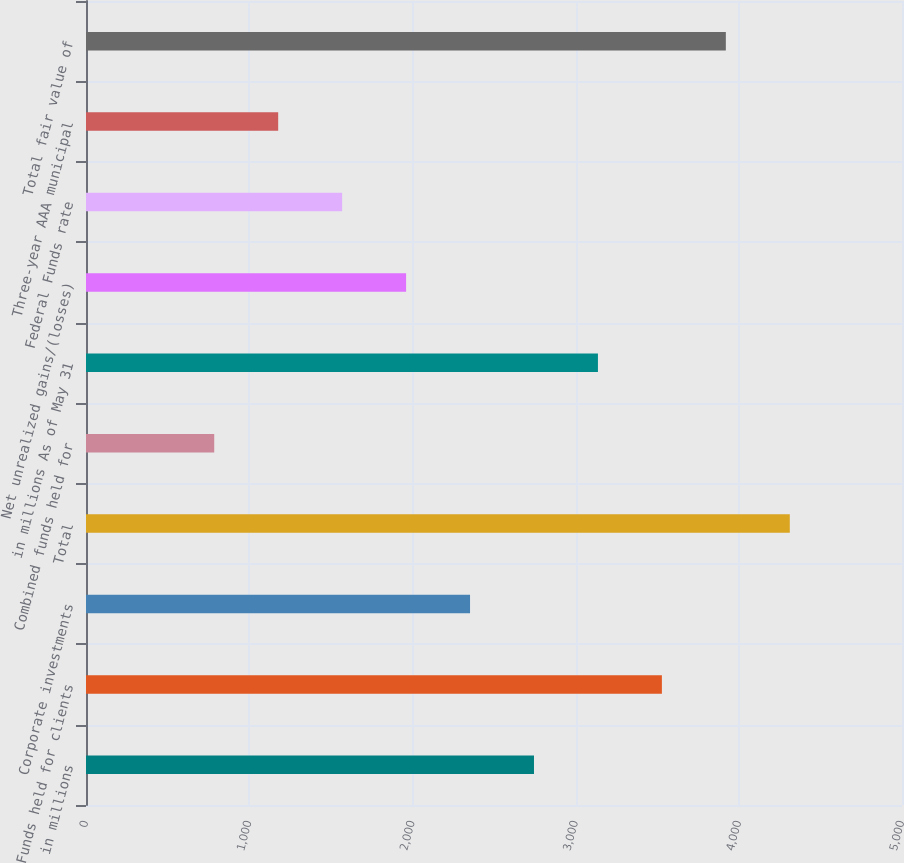Convert chart. <chart><loc_0><loc_0><loc_500><loc_500><bar_chart><fcel>in millions<fcel>Funds held for clients<fcel>Corporate investments<fcel>Total<fcel>Combined funds held for<fcel>in millions As of May 31<fcel>Net unrealized gains/(losses)<fcel>Federal Funds rate<fcel>Three-year AAA municipal<fcel>Total fair value of<nl><fcel>2745.02<fcel>3528.74<fcel>2353.16<fcel>4312.46<fcel>785.72<fcel>3136.88<fcel>1961.3<fcel>1569.44<fcel>1177.58<fcel>3920.6<nl></chart> 